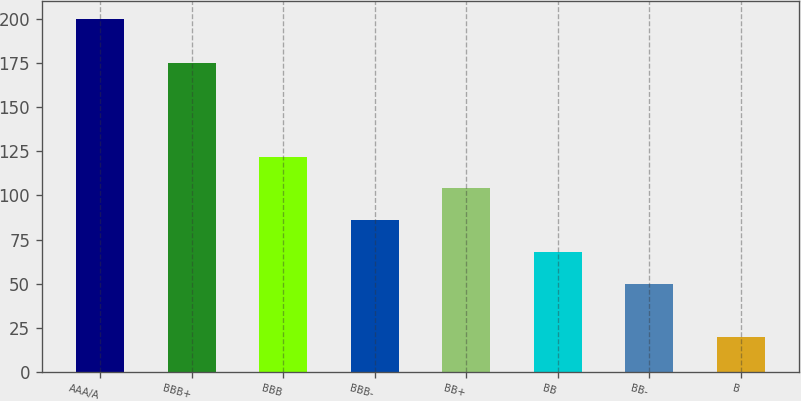<chart> <loc_0><loc_0><loc_500><loc_500><bar_chart><fcel>AAA/A<fcel>BBB+<fcel>BBB<fcel>BBB-<fcel>BB+<fcel>BB<fcel>BB-<fcel>B<nl><fcel>200<fcel>175<fcel>122<fcel>86<fcel>104<fcel>68<fcel>50<fcel>20<nl></chart> 